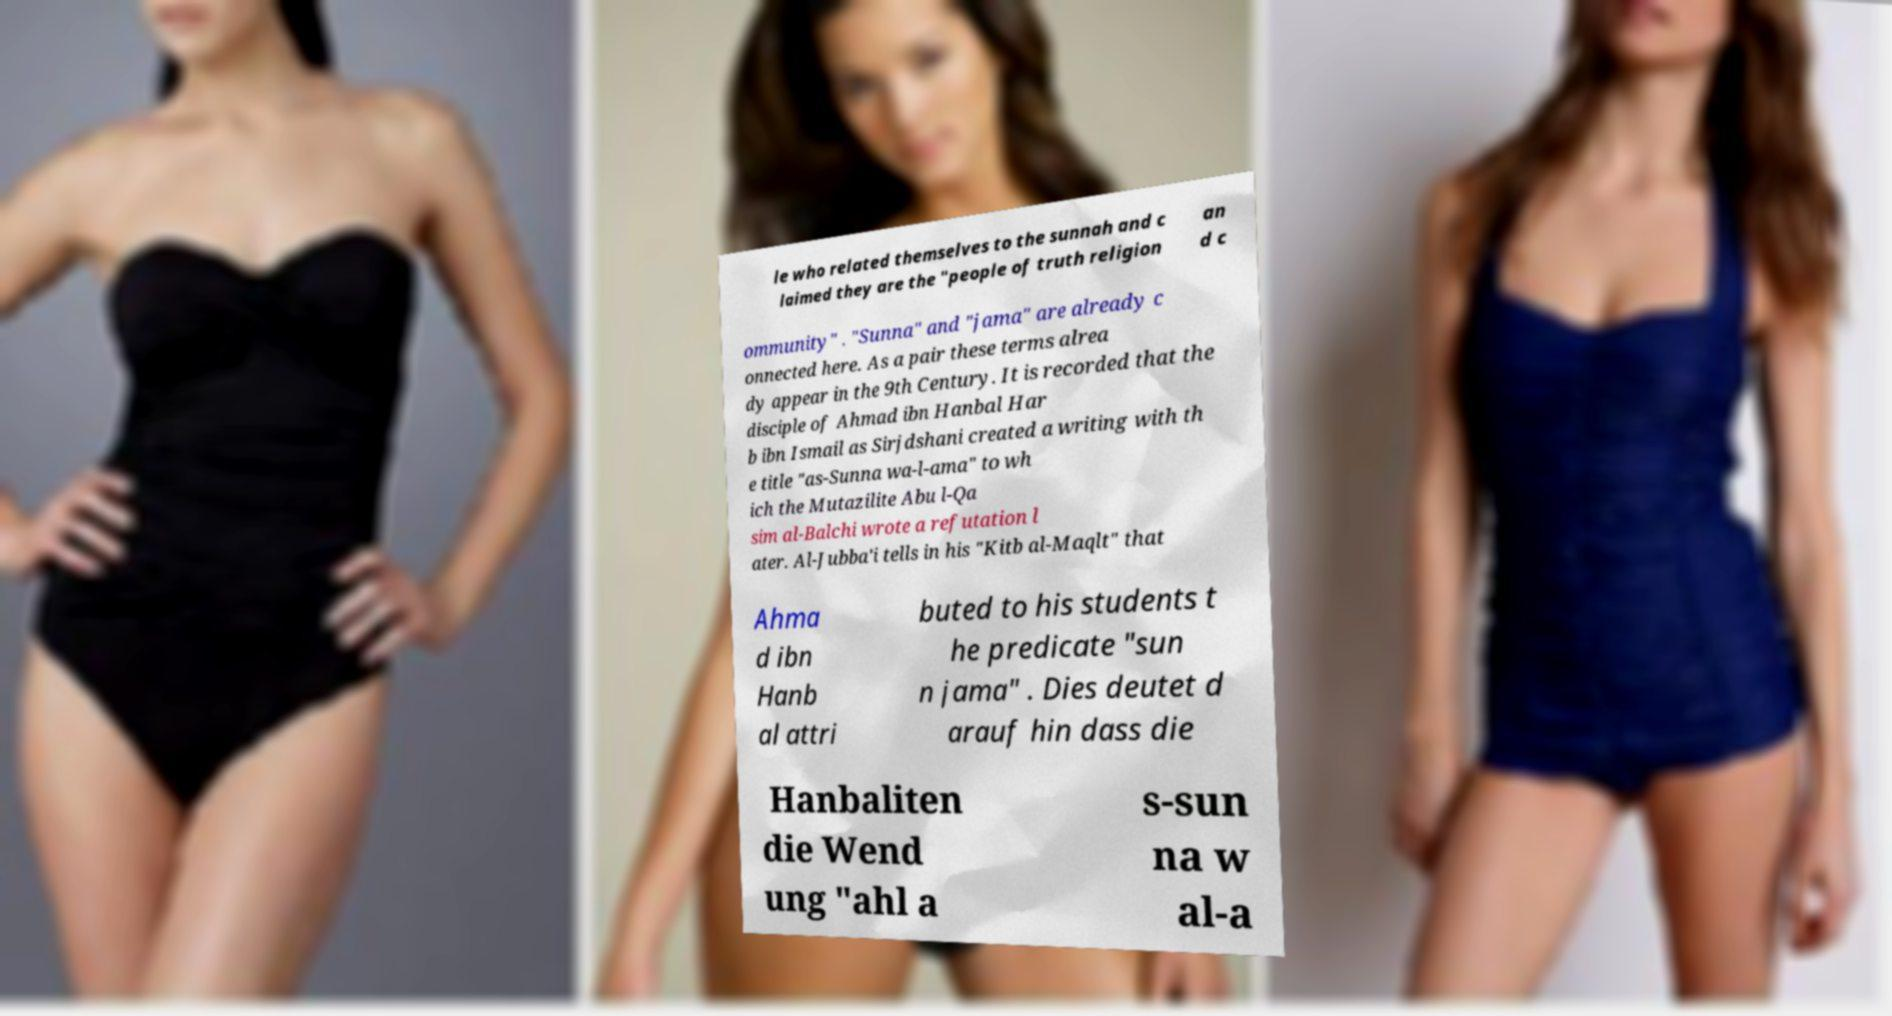Please identify and transcribe the text found in this image. le who related themselves to the sunnah and c laimed they are the "people of truth religion an d c ommunity" . "Sunna" and "jama" are already c onnected here. As a pair these terms alrea dy appear in the 9th Century. It is recorded that the disciple of Ahmad ibn Hanbal Har b ibn Ismail as Sirjdshani created a writing with th e title "as-Sunna wa-l-ama" to wh ich the Mutazilite Abu l-Qa sim al-Balchi wrote a refutation l ater. Al-Jubba'i tells in his "Kitb al-Maqlt" that Ahma d ibn Hanb al attri buted to his students t he predicate "sun n jama" . Dies deutet d arauf hin dass die Hanbaliten die Wend ung "ahl a s-sun na w al-a 